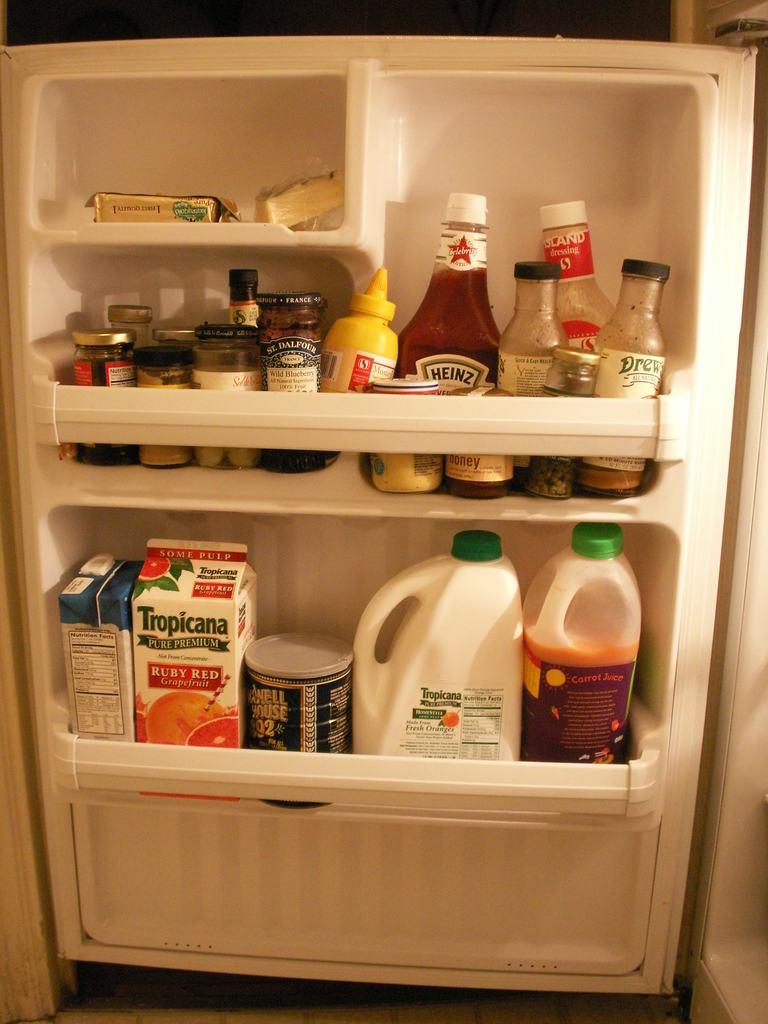What brand of ketchup is in this fridge door?
Your answer should be very brief. Heinz. What brand of orange juice is in the fridge?
Provide a short and direct response. Tropicana. 